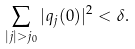<formula> <loc_0><loc_0><loc_500><loc_500>\sum _ { | j | > j _ { 0 } } | q _ { j } ( 0 ) | ^ { 2 } < \delta .</formula> 